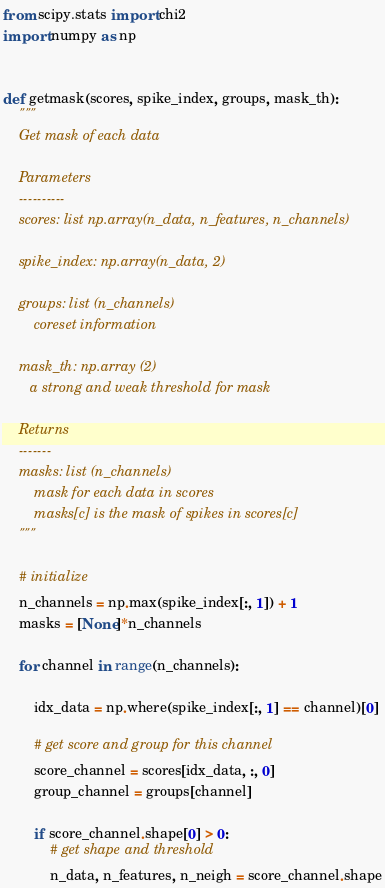<code> <loc_0><loc_0><loc_500><loc_500><_Python_>from scipy.stats import chi2
import numpy as np


def getmask(scores, spike_index, groups, mask_th):
    """
    Get mask of each data

    Parameters
    ----------
    scores: list np.array(n_data, n_features, n_channels)

    spike_index: np.array(n_data, 2)

    groups: list (n_channels)
        coreset information

    mask_th: np.array (2)
       a strong and weak threshold for mask

    Returns
    -------
    masks: list (n_channels)
        mask for each data in scores
        masks[c] is the mask of spikes in scores[c]
    """

    # initialize
    n_channels = np.max(spike_index[:, 1]) + 1
    masks = [None]*n_channels

    for channel in range(n_channels):

        idx_data = np.where(spike_index[:, 1] == channel)[0]

        # get score and group for this channel
        score_channel = scores[idx_data, :, 0]
        group_channel = groups[channel]

        if score_channel.shape[0] > 0:
            # get shape and threshold
            n_data, n_features, n_neigh = score_channel.shape</code> 